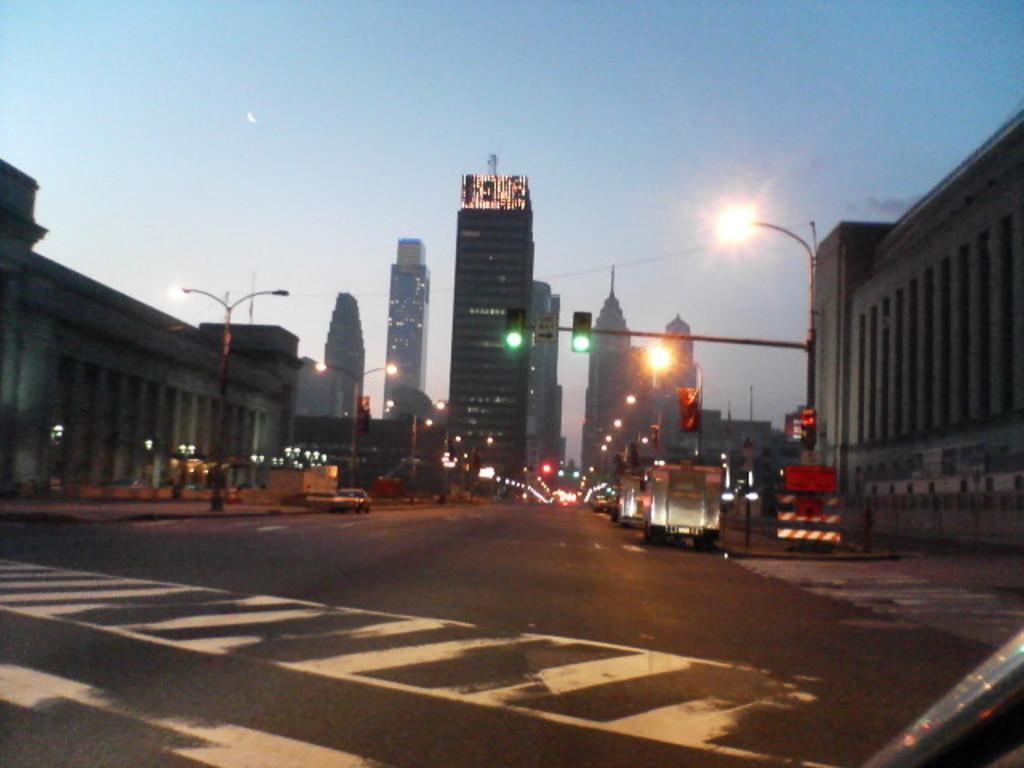What type of pathway is visible in the image? There is a road in the image. What structures can be seen alongside the road? There are buildings in the image. What are the light sources along the road? Light poles are visible in the image. How do vehicles navigate the road? Traffic signals are present in the image to guide vehicles. What types of vehicles are in the image? Vehicles are in the image, but the specific types are not mentioned. What can be seen in the background of the image? The sky is visible in the background of the image. How many cherries are hanging from the traffic signals in the image? There are no cherries present in the image, as it features a road, buildings, light poles, traffic signals, and vehicles. What type of pump is visible in the image? There is no pump present in the image. 